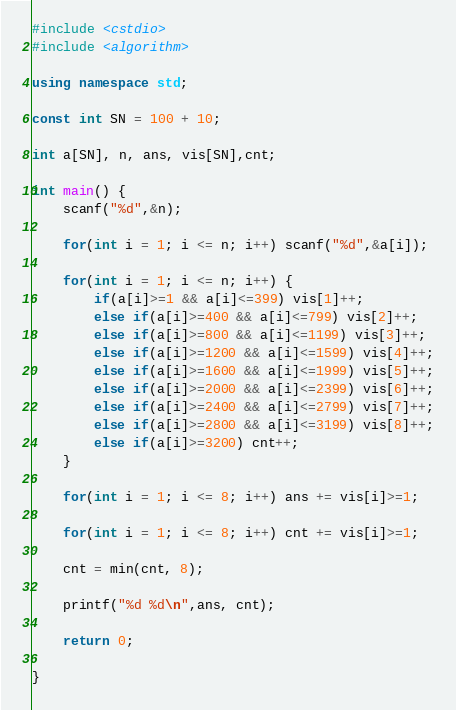<code> <loc_0><loc_0><loc_500><loc_500><_C++_>#include <cstdio>
#include <algorithm>

using namespace std;

const int SN = 100 + 10;

int a[SN], n, ans, vis[SN],cnt;

int main() {
	scanf("%d",&n);
	
	for(int i = 1; i <= n; i++) scanf("%d",&a[i]);
	
	for(int i = 1; i <= n; i++) {
		if(a[i]>=1 && a[i]<=399) vis[1]++;
		else if(a[i]>=400 && a[i]<=799) vis[2]++;
		else if(a[i]>=800 && a[i]<=1199) vis[3]++;
		else if(a[i]>=1200 && a[i]<=1599) vis[4]++;
		else if(a[i]>=1600 && a[i]<=1999) vis[5]++;
		else if(a[i]>=2000 && a[i]<=2399) vis[6]++;
		else if(a[i]>=2400 && a[i]<=2799) vis[7]++;
		else if(a[i]>=2800 && a[i]<=3199) vis[8]++;
		else if(a[i]>=3200) cnt++;
	}
	
	for(int i = 1; i <= 8; i++) ans += vis[i]>=1;
	
	for(int i = 1; i <= 8; i++) cnt += vis[i]>=1;
	
	cnt = min(cnt, 8);
	
	printf("%d %d\n",ans, cnt);
	
	return 0;
	
}</code> 